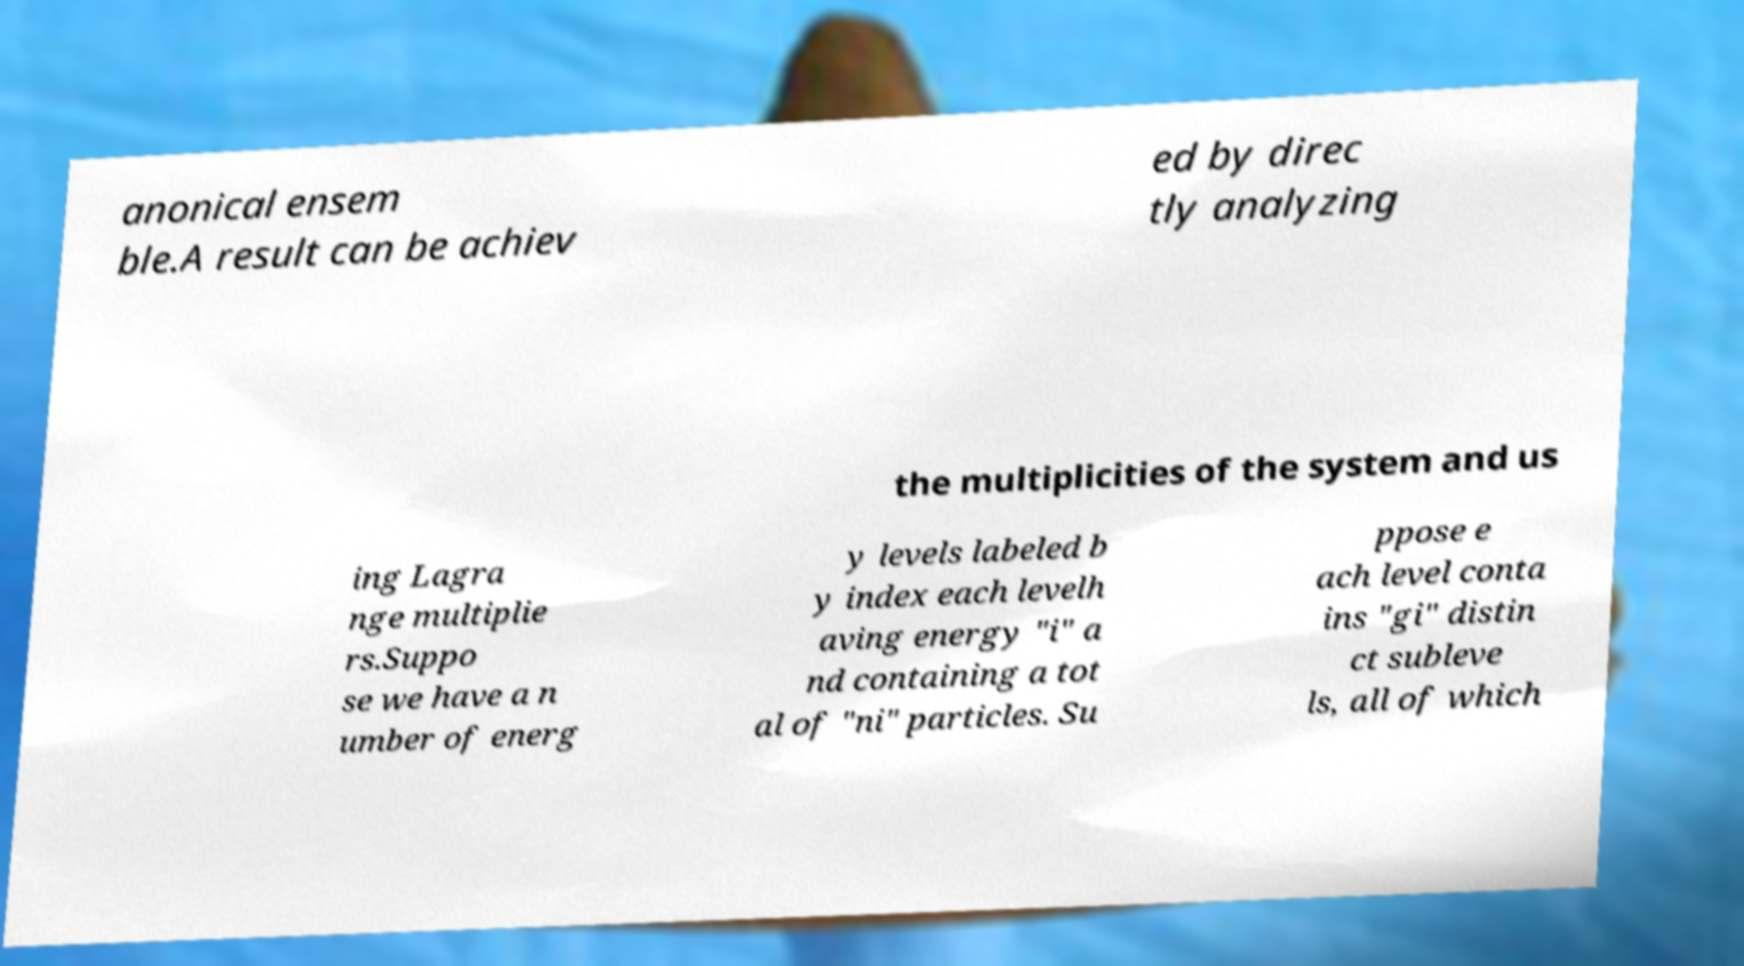Could you extract and type out the text from this image? anonical ensem ble.A result can be achiev ed by direc tly analyzing the multiplicities of the system and us ing Lagra nge multiplie rs.Suppo se we have a n umber of energ y levels labeled b y index each levelh aving energy "i" a nd containing a tot al of "ni" particles. Su ppose e ach level conta ins "gi" distin ct subleve ls, all of which 